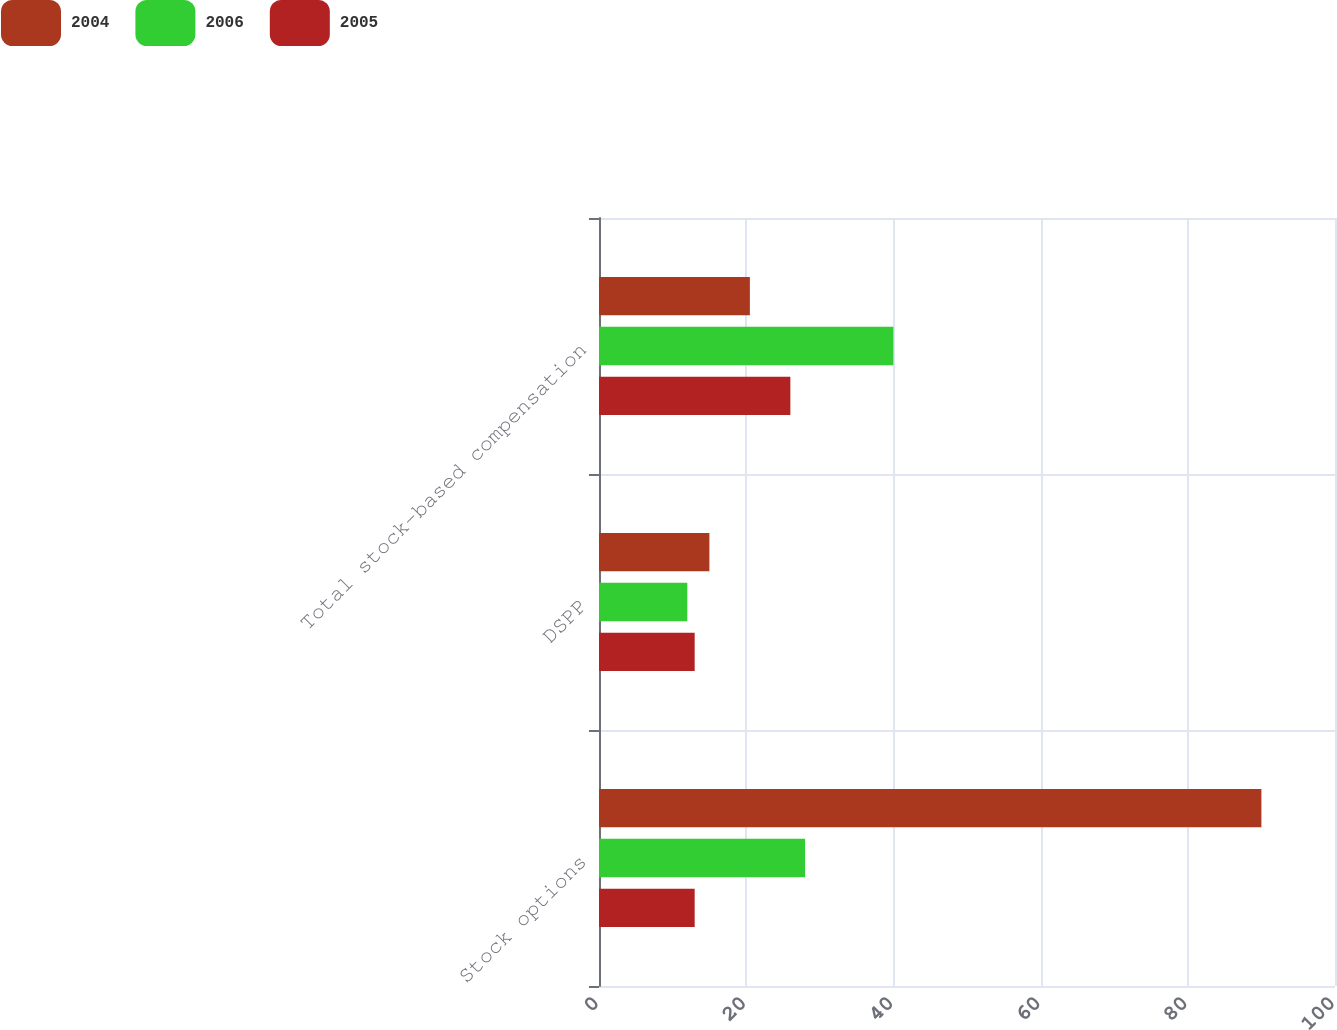Convert chart. <chart><loc_0><loc_0><loc_500><loc_500><stacked_bar_chart><ecel><fcel>Stock options<fcel>DSPP<fcel>Total stock-based compensation<nl><fcel>2004<fcel>90<fcel>15<fcel>20.5<nl><fcel>2006<fcel>28<fcel>12<fcel>40<nl><fcel>2005<fcel>13<fcel>13<fcel>26<nl></chart> 